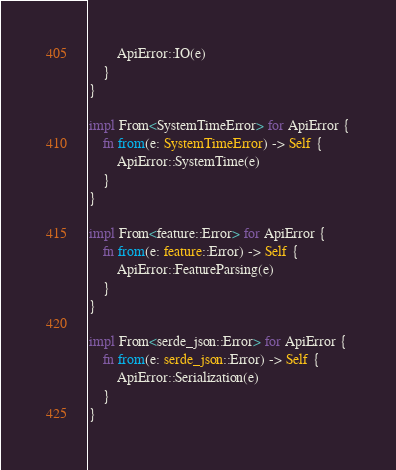Convert code to text. <code><loc_0><loc_0><loc_500><loc_500><_Rust_>        ApiError::IO(e)
    }
}

impl From<SystemTimeError> for ApiError {
    fn from(e: SystemTimeError) -> Self {
        ApiError::SystemTime(e)
    }
}

impl From<feature::Error> for ApiError {
    fn from(e: feature::Error) -> Self {
        ApiError::FeatureParsing(e)
    }
}

impl From<serde_json::Error> for ApiError {
    fn from(e: serde_json::Error) -> Self {
        ApiError::Serialization(e)
    }
}
</code> 